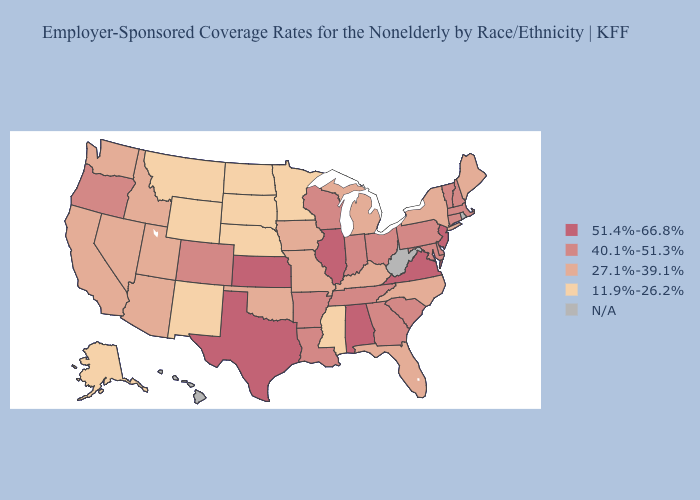What is the lowest value in the MidWest?
Write a very short answer. 11.9%-26.2%. What is the highest value in states that border Virginia?
Give a very brief answer. 40.1%-51.3%. Among the states that border Pennsylvania , does Ohio have the lowest value?
Quick response, please. No. Name the states that have a value in the range 51.4%-66.8%?
Answer briefly. Alabama, Illinois, Kansas, New Jersey, Texas, Virginia. What is the value of West Virginia?
Keep it brief. N/A. Name the states that have a value in the range N/A?
Concise answer only. Hawaii, Rhode Island, West Virginia. What is the highest value in the USA?
Give a very brief answer. 51.4%-66.8%. What is the value of New York?
Answer briefly. 27.1%-39.1%. What is the value of Tennessee?
Give a very brief answer. 40.1%-51.3%. 